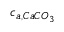<formula> <loc_0><loc_0><loc_500><loc_500>c _ { a , C a C O _ { 3 } }</formula> 